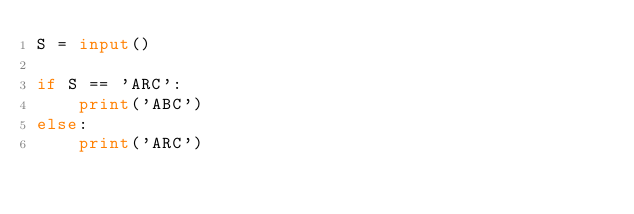<code> <loc_0><loc_0><loc_500><loc_500><_Python_>S = input()

if S == 'ARC':
    print('ABC')
else:
    print('ARC')</code> 